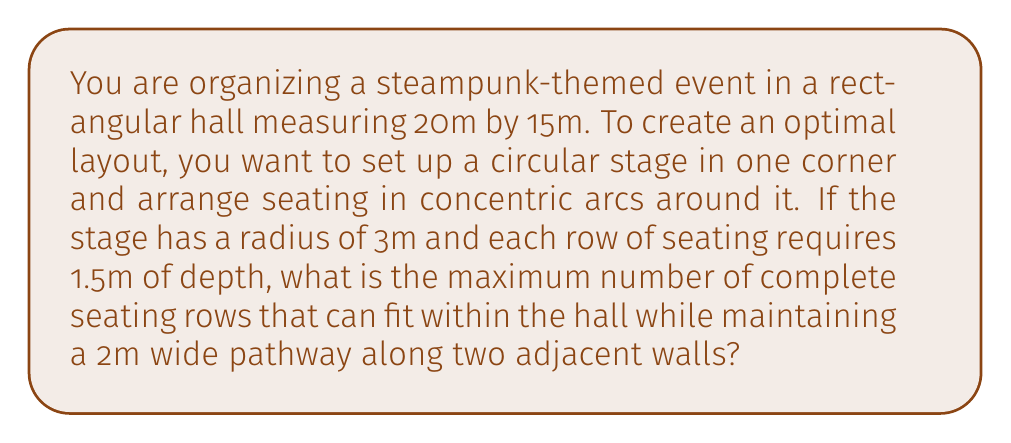Show me your answer to this math problem. Let's approach this step-by-step:

1) First, we need to determine the available space for seating. The stage occupies a quarter-circle in one corner, and we need to leave a 2m pathway along two adjacent walls.

2) The area available for seating can be represented as a quarter-circle with radius R, where R is the distance from the stage center to the opposite corner of the available space.

3) We can calculate R using the Pythagorean theorem:
   $$ R^2 = (20 - 2)^2 + (15 - 2)^2 = 18^2 + 13^2 = 505 $$
   $$ R = \sqrt{505} \approx 22.47m $$

4) The radius of the first seating row will be 3m (stage radius) + 1.5m (row depth) = 4.5m

5) Each subsequent row will increase the radius by 1.5m. We can represent the radius of the nth row as:
   $$ r_n = 3 + 1.5n $$

6) We need to find the largest n for which $r_n \leq R$:
   $$ 3 + 1.5n \leq 22.47 $$
   $$ 1.5n \leq 19.47 $$
   $$ n \leq 12.98 $$

7) Since we can only have whole numbers of rows, the maximum number of complete rows is 12.

[asy]
size(200);
draw((0,0)--(20,0)--(20,15)--(0,15)--cycle);
draw((2,0)--(2,15));
draw((0,2)--(20,2));
draw(arc((0,0),3,0,90));
for(int i=1; i<=12; ++i) {
  draw(arc((0,0),3+1.5*i,0,90),dashed);
}
label("Stage",(-1.5,1.5));
label("Seating",(10,7.5));
label("Pathway",(1,14));
label("20m",(10,-1));
label("15m",(21,7.5));
[/asy]
Answer: 12 rows 